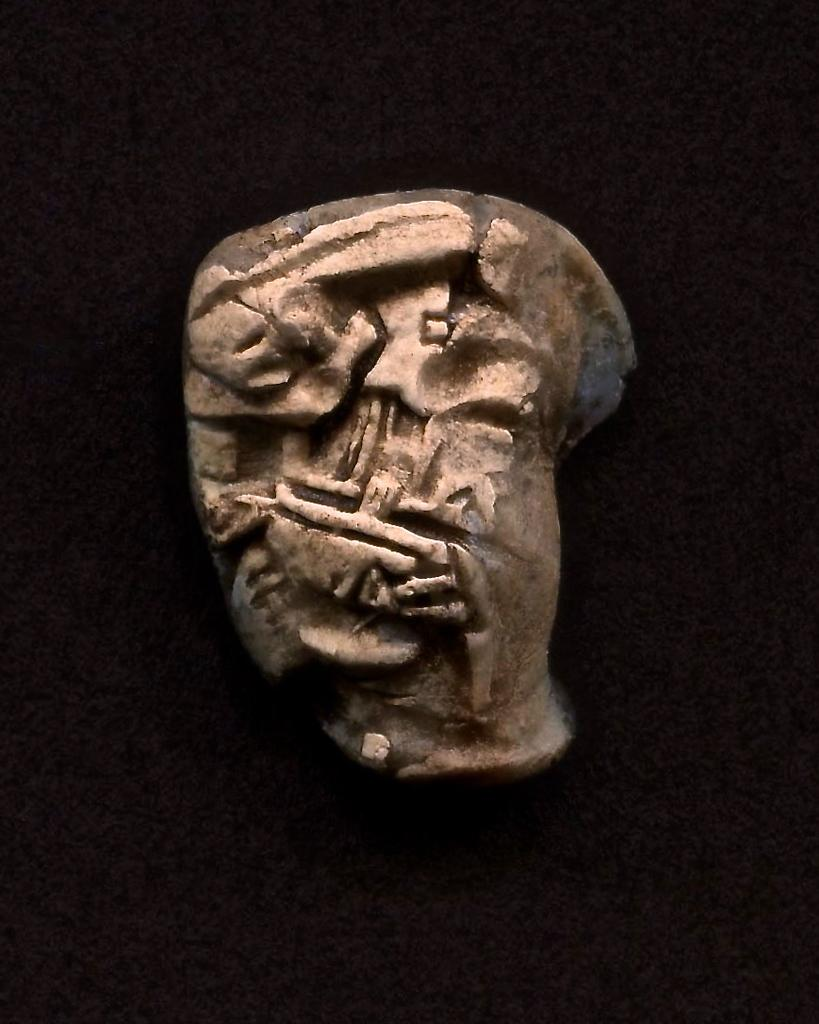What is the main subject of the image? The main subject of the image is a rock. What can be observed about the background of the image? The background of the image is dark. What type of hook is attached to the rock in the image? There is no hook present in the image; it only features a rock with a dark background. How many fingers can be seen touching the rock in the image? There are no fingers or hands visible in the image, as it only features a rock with a dark background. 